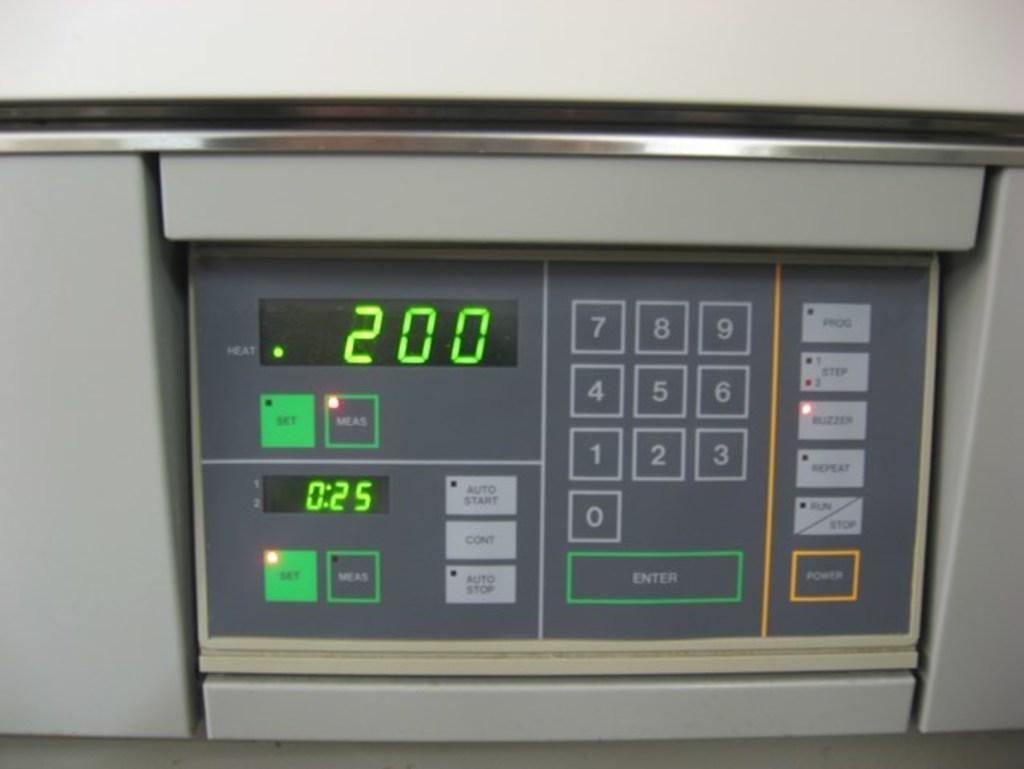Please provide a concise description of this image. In this image we can see an electronic device. 